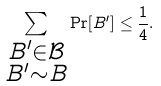Convert formula to latex. <formula><loc_0><loc_0><loc_500><loc_500>\sum _ { \substack { B ^ { \prime } \in \mathcal { B } \\ B ^ { \prime } \sim B } } \Pr [ B ^ { \prime } ] \leq \frac { 1 } { 4 } .</formula> 